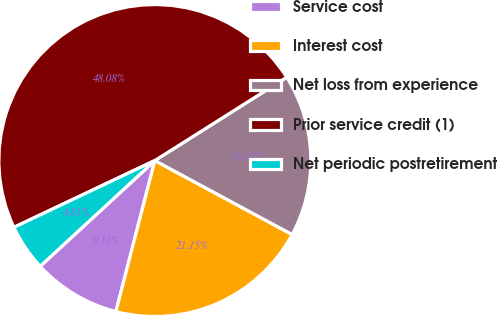<chart> <loc_0><loc_0><loc_500><loc_500><pie_chart><fcel>Service cost<fcel>Interest cost<fcel>Net loss from experience<fcel>Prior service credit (1)<fcel>Net periodic postretirement<nl><fcel>9.13%<fcel>21.15%<fcel>16.83%<fcel>48.08%<fcel>4.81%<nl></chart> 